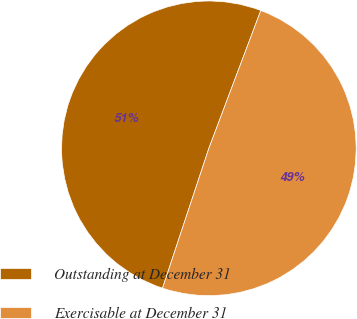<chart> <loc_0><loc_0><loc_500><loc_500><pie_chart><fcel>Outstanding at December 31<fcel>Exercisable at December 31<nl><fcel>50.64%<fcel>49.36%<nl></chart> 